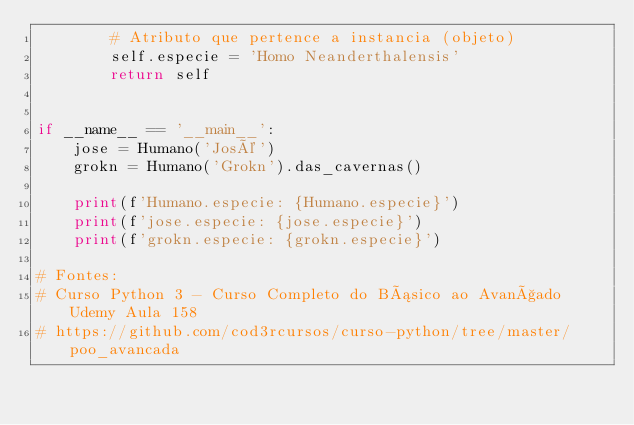Convert code to text. <code><loc_0><loc_0><loc_500><loc_500><_Python_>        # Atributo que pertence a instancia (objeto)
        self.especie = 'Homo Neanderthalensis'
        return self


if __name__ == '__main__':
    jose = Humano('José')
    grokn = Humano('Grokn').das_cavernas()

    print(f'Humano.especie: {Humano.especie}')
    print(f'jose.especie: {jose.especie}')
    print(f'grokn.especie: {grokn.especie}')

# Fontes:
# Curso Python 3 - Curso Completo do Básico ao Avançado Udemy Aula 158
# https://github.com/cod3rcursos/curso-python/tree/master/poo_avancada
</code> 